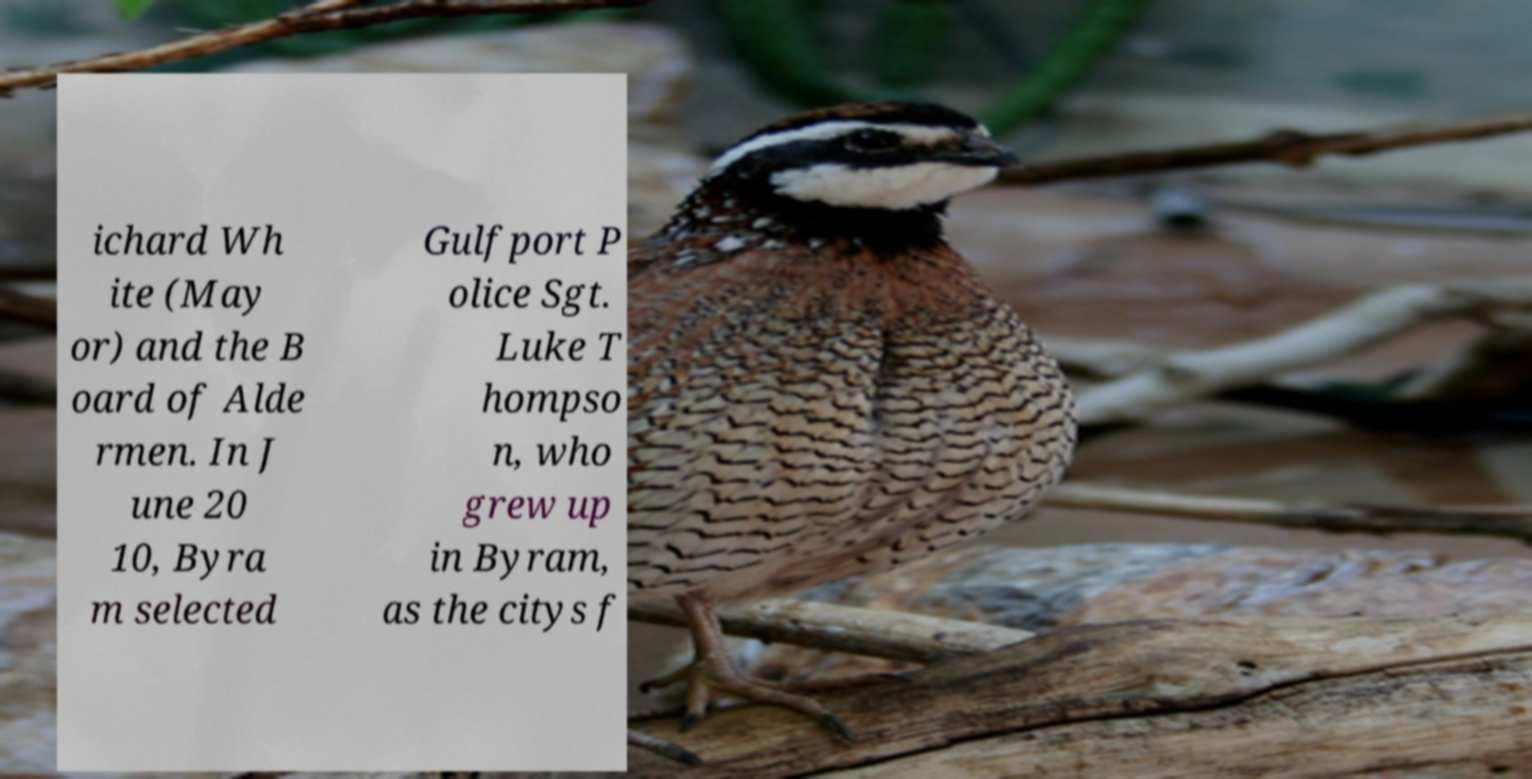There's text embedded in this image that I need extracted. Can you transcribe it verbatim? ichard Wh ite (May or) and the B oard of Alde rmen. In J une 20 10, Byra m selected Gulfport P olice Sgt. Luke T hompso n, who grew up in Byram, as the citys f 